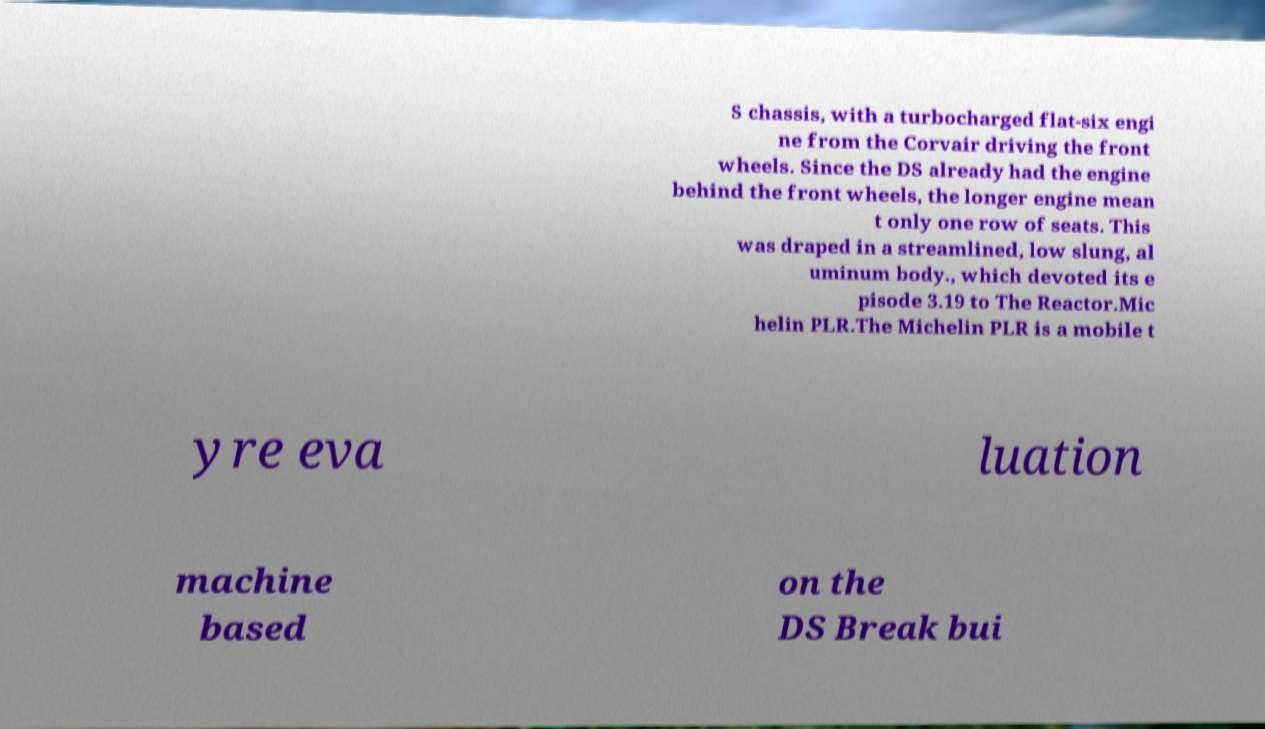I need the written content from this picture converted into text. Can you do that? S chassis, with a turbocharged flat-six engi ne from the Corvair driving the front wheels. Since the DS already had the engine behind the front wheels, the longer engine mean t only one row of seats. This was draped in a streamlined, low slung, al uminum body., which devoted its e pisode 3.19 to The Reactor.Mic helin PLR.The Michelin PLR is a mobile t yre eva luation machine based on the DS Break bui 